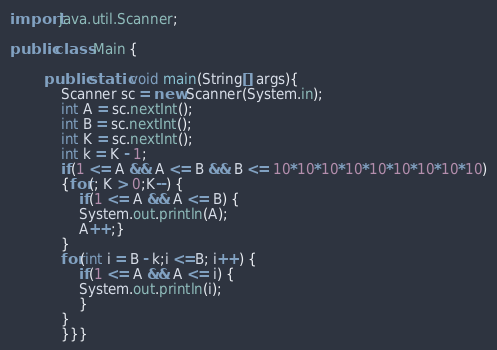Convert code to text. <code><loc_0><loc_0><loc_500><loc_500><_Java_>import java.util.Scanner;

public class Main {

		public static void main(String[] args){
			Scanner sc = new Scanner(System.in);
			int A = sc.nextInt();
			int B = sc.nextInt();
			int K = sc.nextInt();
			int k = K - 1;
			if(1 <= A && A <= B && B <= 10*10*10*10*10*10*10*10*10)
			{for(; K > 0;K--) {
				if(1 <= A && A <= B) {
				System.out.println(A);
				A++;}
			}
			for(int i = B - k;i <=B; i++) {
				if(1 <= A && A <= i) {
				System.out.println(i);
				}
			}
			}}}</code> 